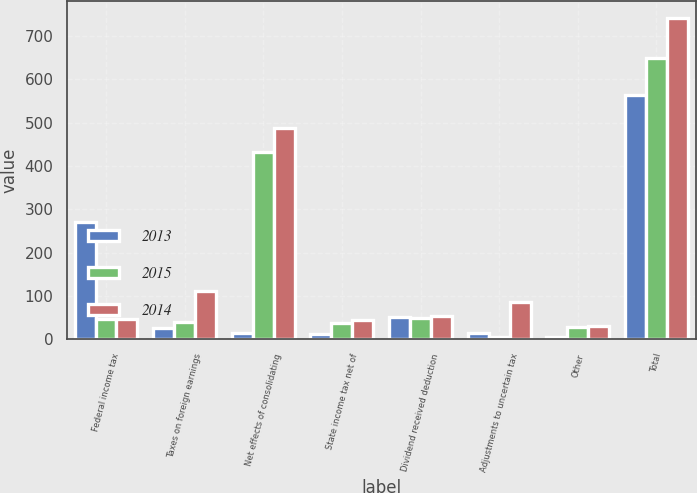Convert chart to OTSL. <chart><loc_0><loc_0><loc_500><loc_500><stacked_bar_chart><ecel><fcel>Federal income tax<fcel>Taxes on foreign earnings<fcel>Net effects of consolidating<fcel>State income tax net of<fcel>Dividend received deduction<fcel>Adjustments to uncertain tax<fcel>Other<fcel>Total<nl><fcel>2013<fcel>271<fcel>26<fcel>15<fcel>12<fcel>51<fcel>14<fcel>6<fcel>564<nl><fcel>2015<fcel>47.5<fcel>40<fcel>433<fcel>37<fcel>50<fcel>5<fcel>28<fcel>648<nl><fcel>2014<fcel>47.5<fcel>112<fcel>488<fcel>45<fcel>54<fcel>87<fcel>32<fcel>742<nl></chart> 